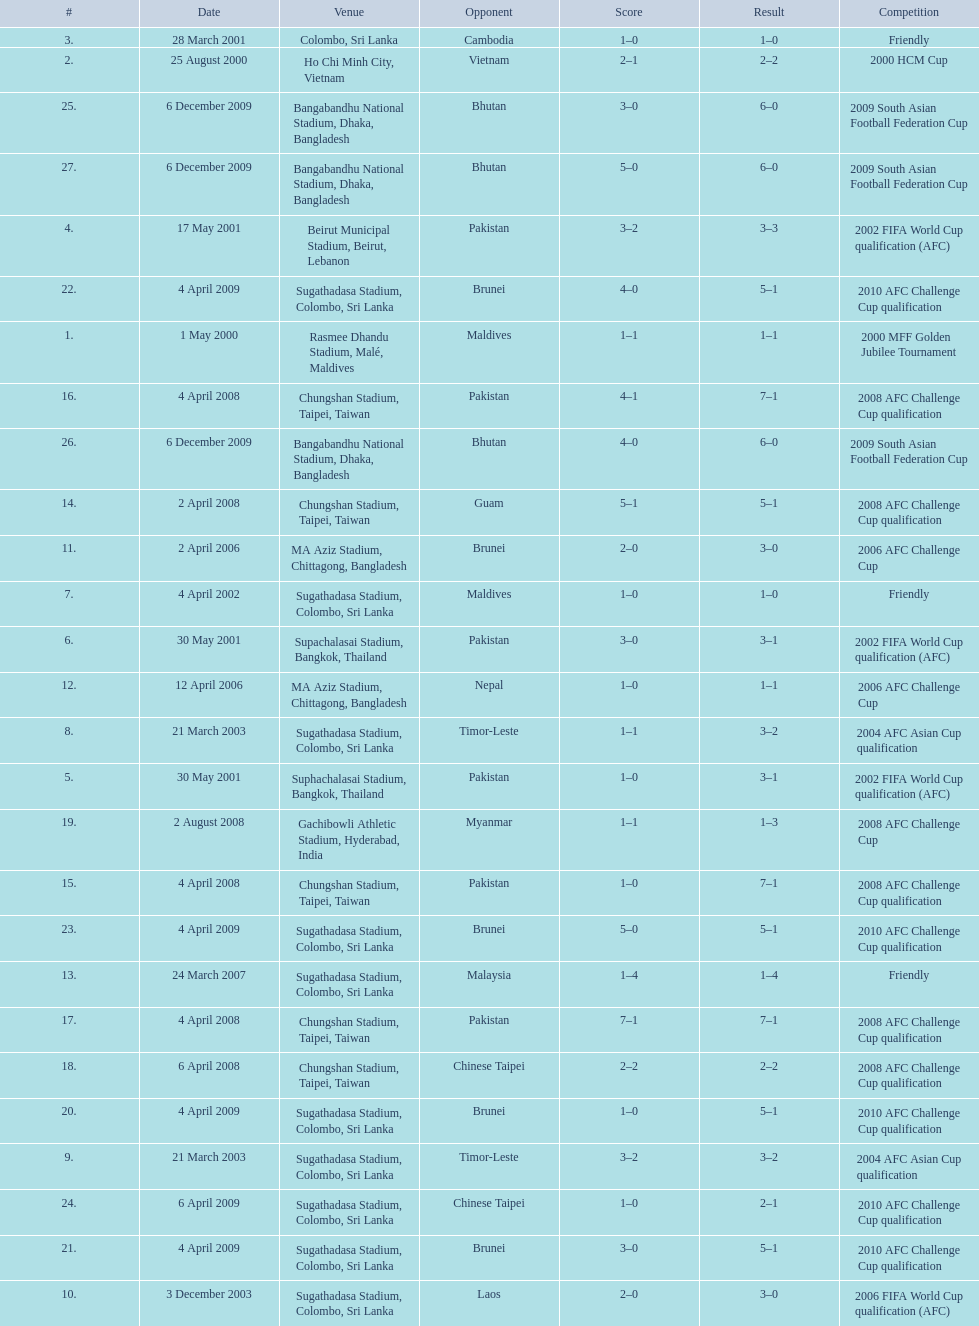How many venues are in the table? 27. Which one is the top listed? Rasmee Dhandu Stadium, Malé, Maldives. 